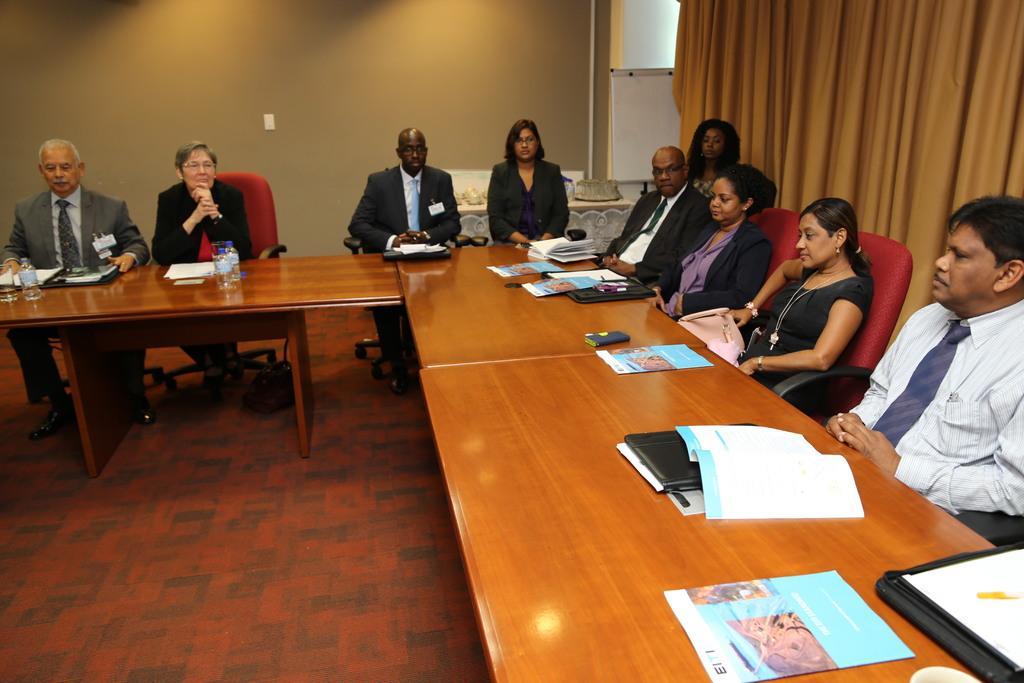In one or two sentences, can you explain what this image depicts? In this picture we can see some persons sitting on the chairs. This is table. On the table there are books, files, and bottles. This is floor. On the background there is a wall and this is curtain. Here we can see a board. 